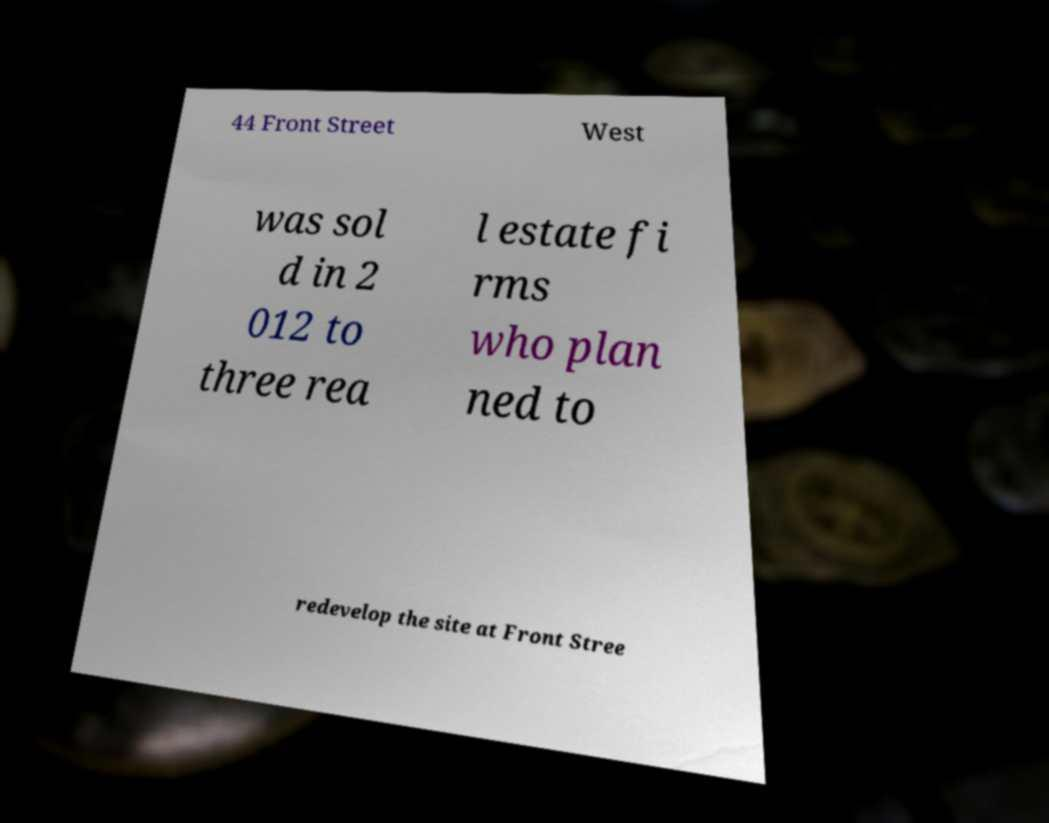I need the written content from this picture converted into text. Can you do that? 44 Front Street West was sol d in 2 012 to three rea l estate fi rms who plan ned to redevelop the site at Front Stree 